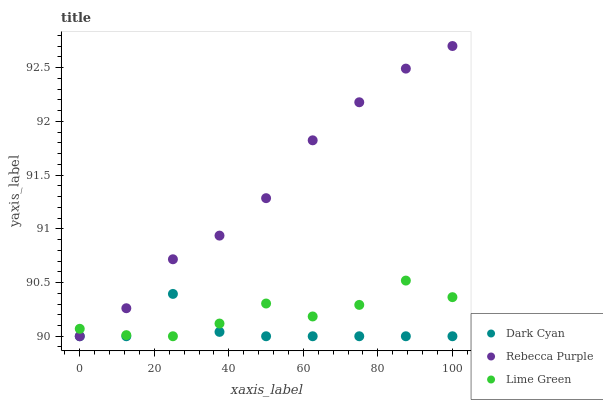Does Dark Cyan have the minimum area under the curve?
Answer yes or no. Yes. Does Rebecca Purple have the maximum area under the curve?
Answer yes or no. Yes. Does Lime Green have the minimum area under the curve?
Answer yes or no. No. Does Lime Green have the maximum area under the curve?
Answer yes or no. No. Is Rebecca Purple the smoothest?
Answer yes or no. Yes. Is Dark Cyan the roughest?
Answer yes or no. Yes. Is Lime Green the smoothest?
Answer yes or no. No. Is Lime Green the roughest?
Answer yes or no. No. Does Dark Cyan have the lowest value?
Answer yes or no. Yes. Does Rebecca Purple have the highest value?
Answer yes or no. Yes. Does Lime Green have the highest value?
Answer yes or no. No. Does Lime Green intersect Dark Cyan?
Answer yes or no. Yes. Is Lime Green less than Dark Cyan?
Answer yes or no. No. Is Lime Green greater than Dark Cyan?
Answer yes or no. No. 